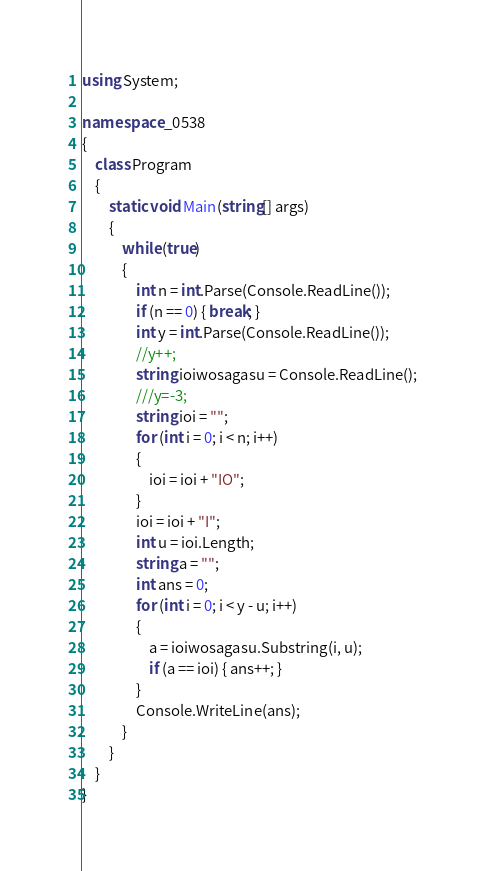Convert code to text. <code><loc_0><loc_0><loc_500><loc_500><_C#_>using System;

namespace _0538
{
    class Program
    {
        static void Main(string[] args)
        {
            while (true)
            {
                int n = int.Parse(Console.ReadLine());
                if (n == 0) { break; }
                int y = int.Parse(Console.ReadLine());
                //y++;
                string ioiwosagasu = Console.ReadLine();
                ///y=-3;
                string ioi = "";
                for (int i = 0; i < n; i++)
                {
                    ioi = ioi + "IO";
                }
                ioi = ioi + "I";
                int u = ioi.Length;
                string a = "";
                int ans = 0;
                for (int i = 0; i < y - u; i++)
                {
                    a = ioiwosagasu.Substring(i, u);
                    if (a == ioi) { ans++; }
                }
                Console.WriteLine(ans);
            }
        }
    }
}</code> 